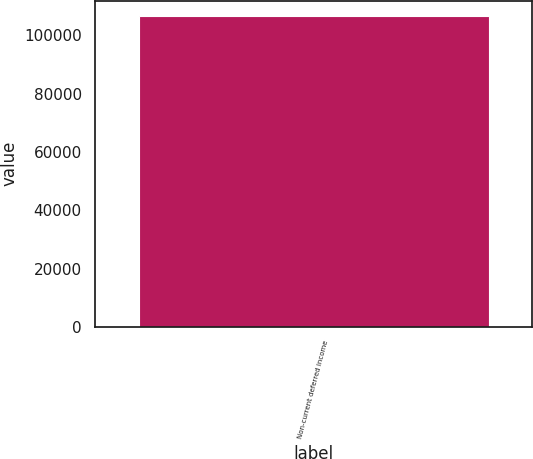Convert chart. <chart><loc_0><loc_0><loc_500><loc_500><bar_chart><fcel>Non-current deferred income<nl><fcel>106644<nl></chart> 